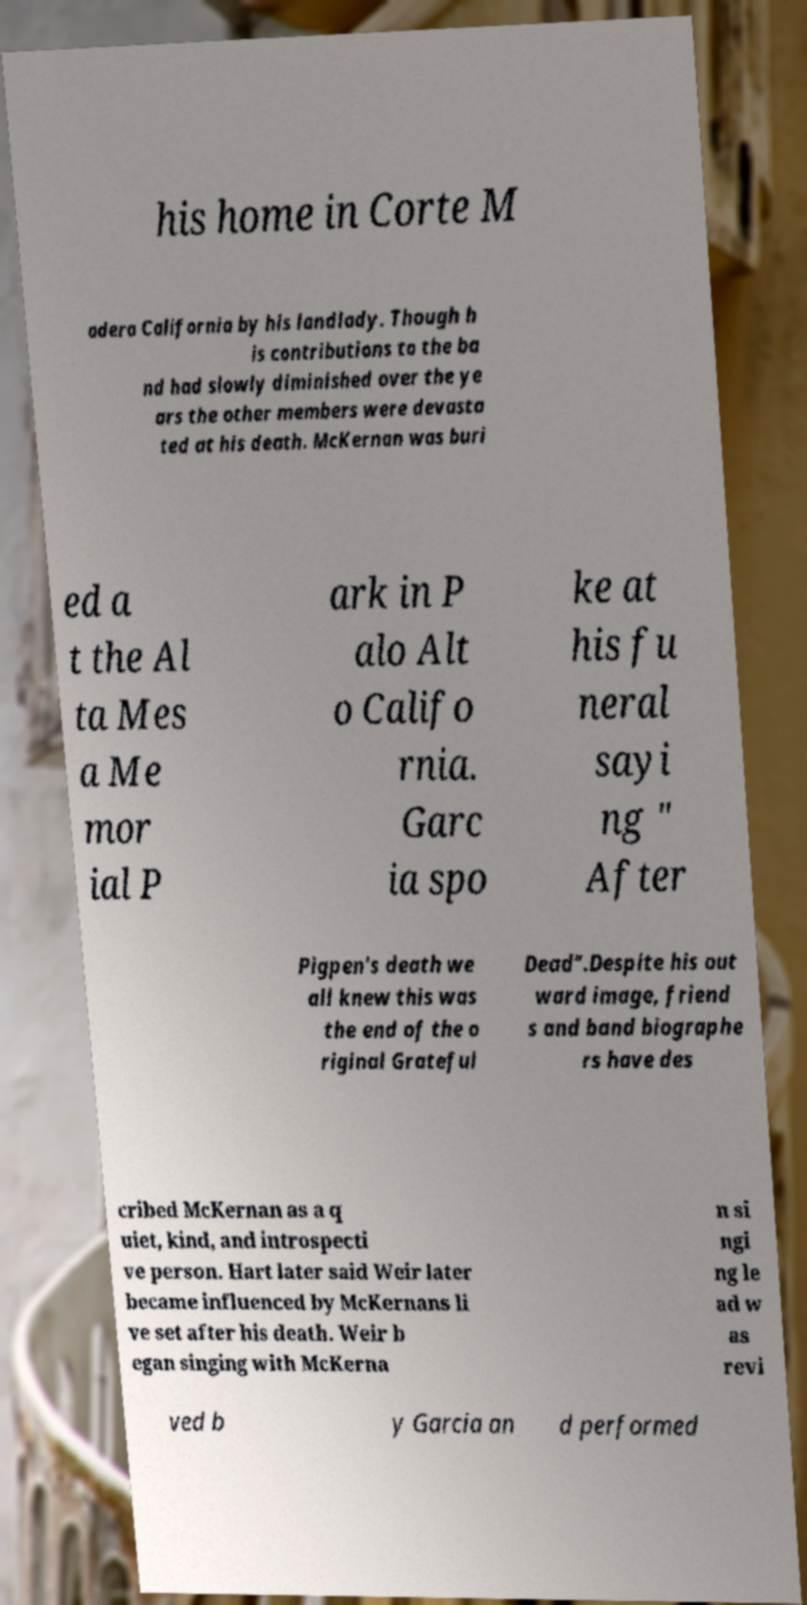For documentation purposes, I need the text within this image transcribed. Could you provide that? his home in Corte M adera California by his landlady. Though h is contributions to the ba nd had slowly diminished over the ye ars the other members were devasta ted at his death. McKernan was buri ed a t the Al ta Mes a Me mor ial P ark in P alo Alt o Califo rnia. Garc ia spo ke at his fu neral sayi ng " After Pigpen's death we all knew this was the end of the o riginal Grateful Dead".Despite his out ward image, friend s and band biographe rs have des cribed McKernan as a q uiet, kind, and introspecti ve person. Hart later said Weir later became influenced by McKernans li ve set after his death. Weir b egan singing with McKerna n si ngi ng le ad w as revi ved b y Garcia an d performed 